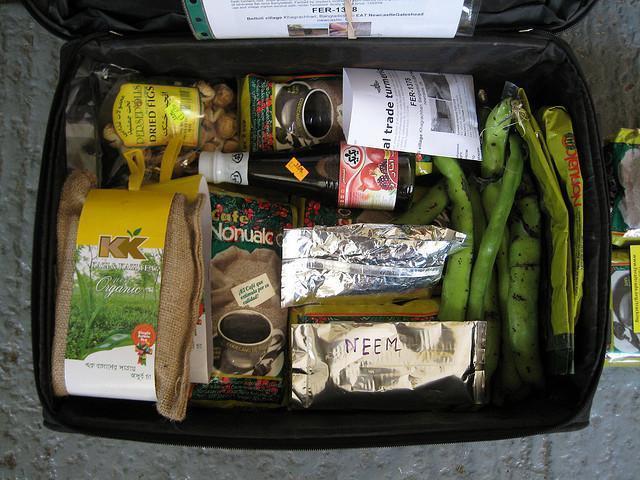How many chairs do you see?
Give a very brief answer. 0. 